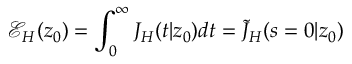<formula> <loc_0><loc_0><loc_500><loc_500>\mathcal { E } _ { H } ( z _ { 0 } ) = \int _ { 0 } ^ { \infty } J _ { H } ( t | z _ { 0 } ) d t = \tilde { J } _ { H } ( s = 0 | z _ { 0 } )</formula> 